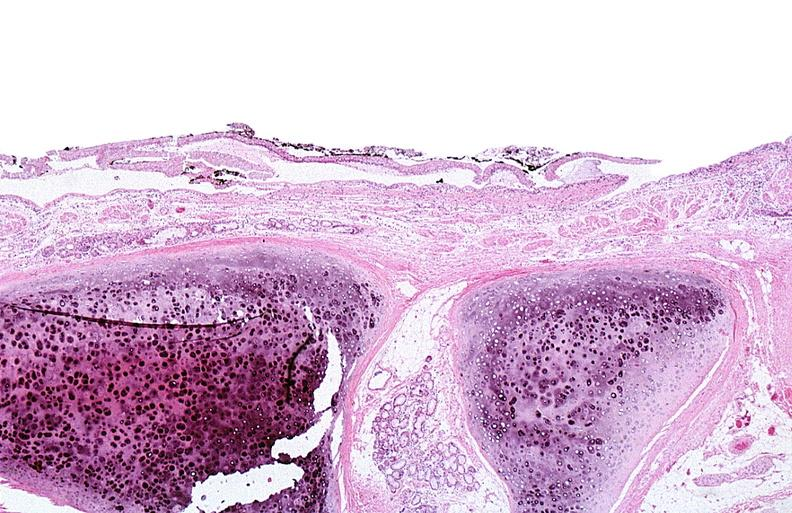what does this image show?
Answer the question using a single word or phrase. Thermal burned skin 